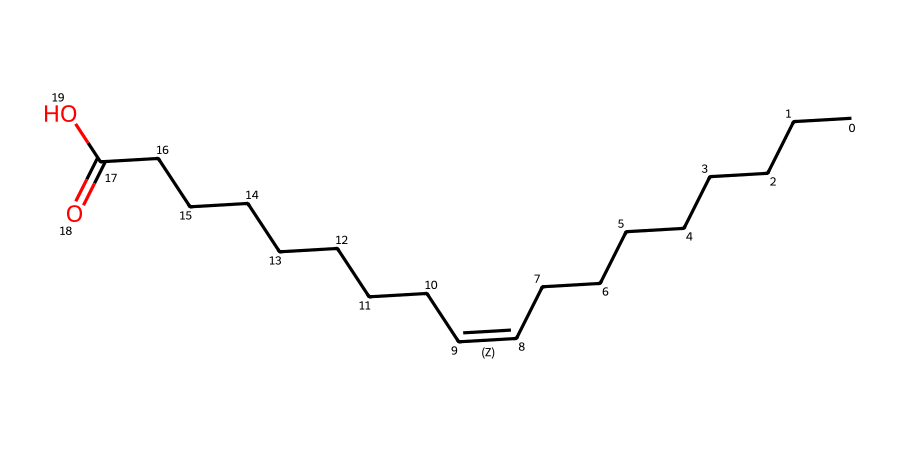What is the total number of carbon atoms in this fatty acid? The chemical structure shows a long chain made up of 'C' atoms. Counting the carbon atoms in the SMILES representation, there are 18 'C' symbols present, indicating 18 carbon atoms.
Answer: 18 How many double bonds does this fatty acid have? In the SMILES representation, the section '/C=C/' indicates a double bond between two carbon atoms. Therefore, there is one double bond in this fatty acid structure.
Answer: 1 What functional group is present in this fatty acid? The presence of the 'O' followed by '(=O)O' at the end of the structure indicates that there is a carboxylic acid functional group (-COOH). This is characteristic of fatty acids.
Answer: carboxylic acid Is this fatty acid saturated or unsaturated? The presence of a double bond (as indicated by '/C=C/') means that this fatty acid can hold fewer hydrogen atoms compared to a saturated fatty acid. Thus, it is unsaturated.
Answer: unsaturated What is the length of the main carbon chain in this fatty acid? Counting the number of carbon atoms in the longest continuous chain (from the beginning to the end, excluding the carboxylic acid part), there are 16 carbon atoms in the chain itself.
Answer: 16 